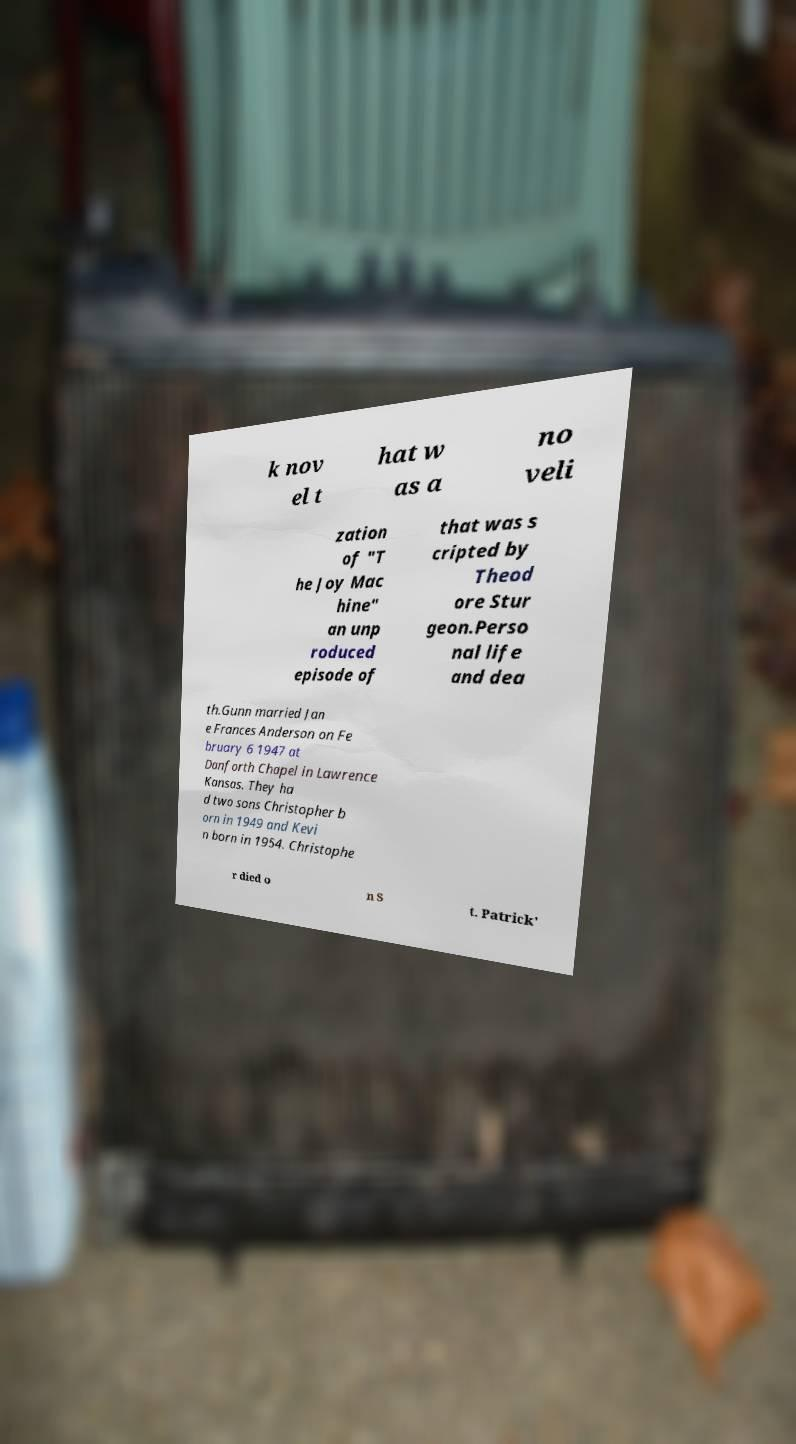Could you assist in decoding the text presented in this image and type it out clearly? k nov el t hat w as a no veli zation of "T he Joy Mac hine" an unp roduced episode of that was s cripted by Theod ore Stur geon.Perso nal life and dea th.Gunn married Jan e Frances Anderson on Fe bruary 6 1947 at Danforth Chapel in Lawrence Kansas. They ha d two sons Christopher b orn in 1949 and Kevi n born in 1954. Christophe r died o n S t. Patrick' 